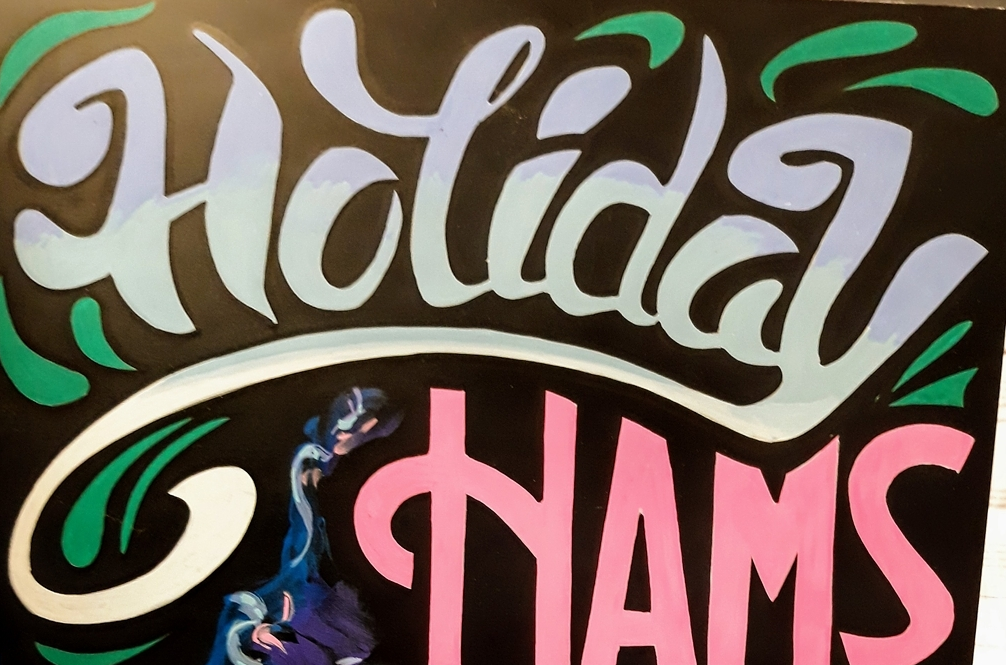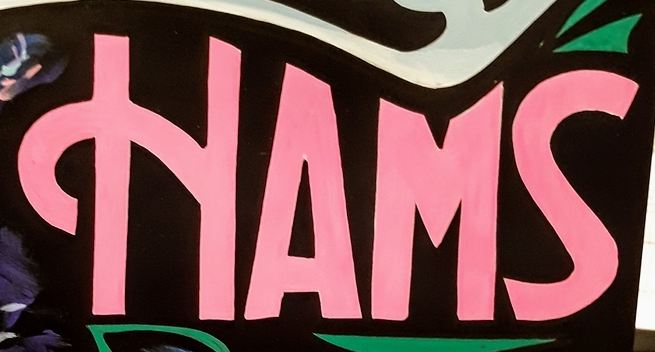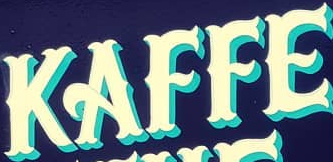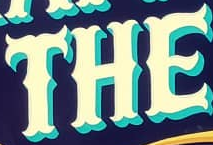Transcribe the words shown in these images in order, separated by a semicolon. Holiday; HAMS; KAFFE; THE 